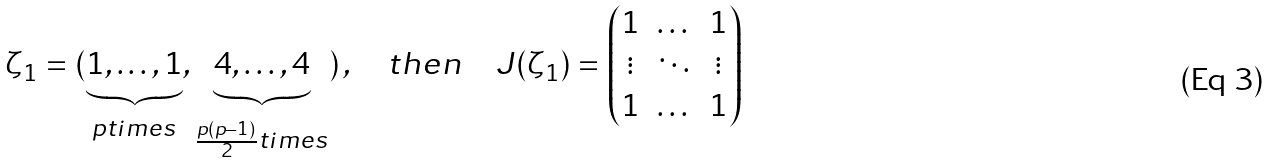<formula> <loc_0><loc_0><loc_500><loc_500>\zeta _ { 1 } = ( \underbrace { 1 , \dots , 1 } _ { p t i m e s } , \underbrace { 4 , \dots , 4 } _ { \frac { p ( p - 1 ) } { 2 } t i m e s } ) \, , \quad t h e n \quad J ( \zeta _ { 1 } ) = \begin{pmatrix} 1 & \dots & 1 \\ \vdots & \ddots & \vdots \\ 1 & \dots & 1 \end{pmatrix}</formula> 